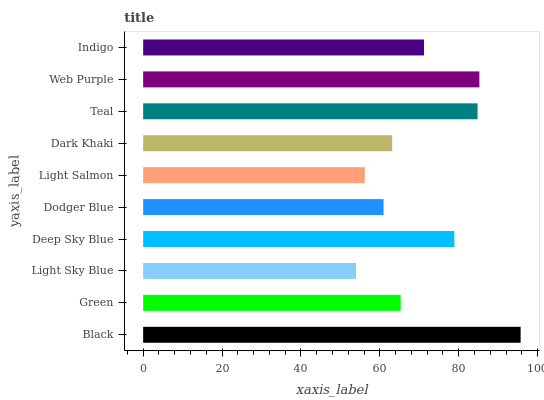Is Light Sky Blue the minimum?
Answer yes or no. Yes. Is Black the maximum?
Answer yes or no. Yes. Is Green the minimum?
Answer yes or no. No. Is Green the maximum?
Answer yes or no. No. Is Black greater than Green?
Answer yes or no. Yes. Is Green less than Black?
Answer yes or no. Yes. Is Green greater than Black?
Answer yes or no. No. Is Black less than Green?
Answer yes or no. No. Is Indigo the high median?
Answer yes or no. Yes. Is Green the low median?
Answer yes or no. Yes. Is Deep Sky Blue the high median?
Answer yes or no. No. Is Teal the low median?
Answer yes or no. No. 